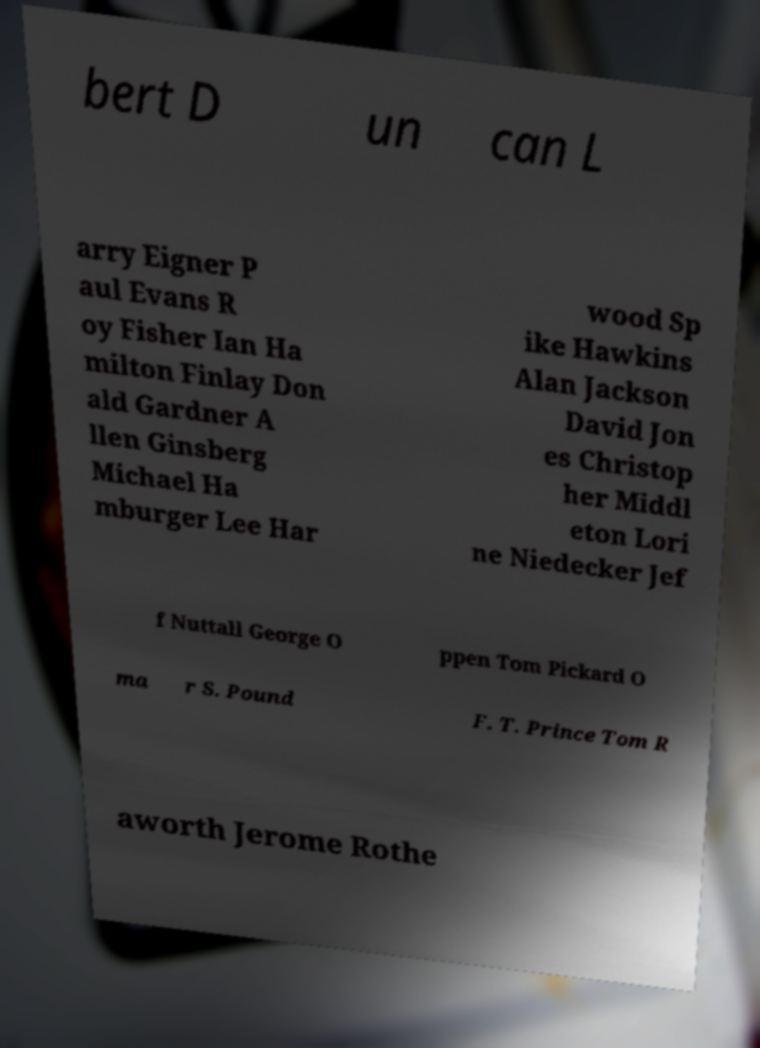Could you assist in decoding the text presented in this image and type it out clearly? bert D un can L arry Eigner P aul Evans R oy Fisher Ian Ha milton Finlay Don ald Gardner A llen Ginsberg Michael Ha mburger Lee Har wood Sp ike Hawkins Alan Jackson David Jon es Christop her Middl eton Lori ne Niedecker Jef f Nuttall George O ppen Tom Pickard O ma r S. Pound F. T. Prince Tom R aworth Jerome Rothe 